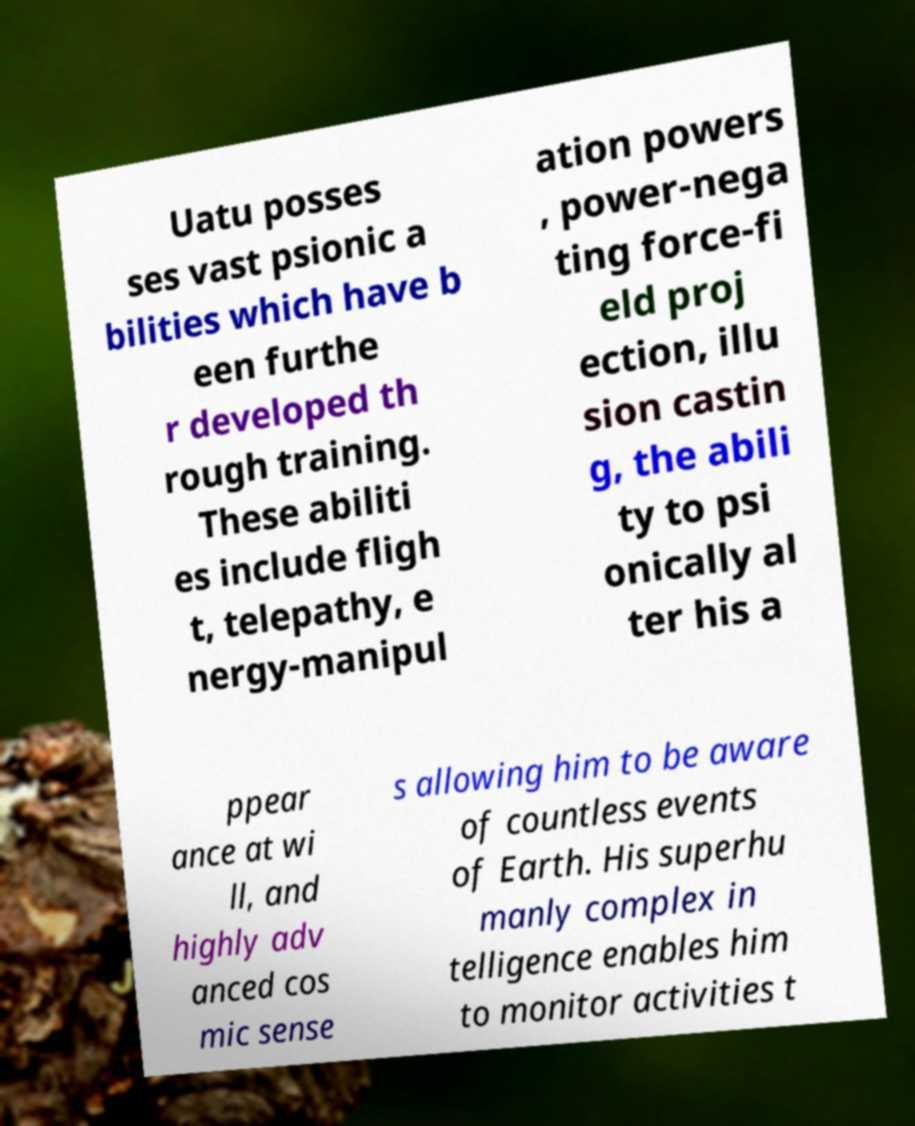Please read and relay the text visible in this image. What does it say? Uatu posses ses vast psionic a bilities which have b een furthe r developed th rough training. These abiliti es include fligh t, telepathy, e nergy-manipul ation powers , power-nega ting force-fi eld proj ection, illu sion castin g, the abili ty to psi onically al ter his a ppear ance at wi ll, and highly adv anced cos mic sense s allowing him to be aware of countless events of Earth. His superhu manly complex in telligence enables him to monitor activities t 